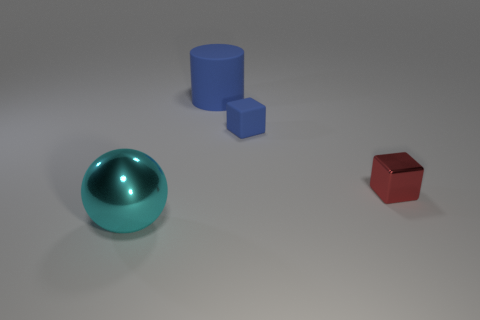Add 4 big gray metallic balls. How many objects exist? 8 Subtract all cylinders. How many objects are left? 3 Subtract 0 gray cylinders. How many objects are left? 4 Subtract all small blue rubber objects. Subtract all small rubber things. How many objects are left? 2 Add 3 metal things. How many metal things are left? 5 Add 1 big yellow balls. How many big yellow balls exist? 1 